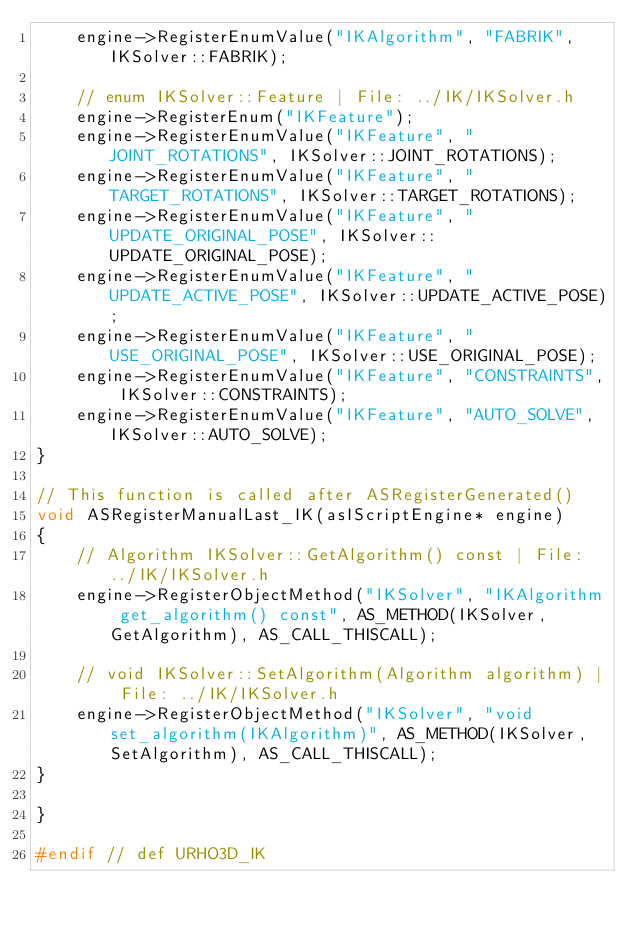<code> <loc_0><loc_0><loc_500><loc_500><_C++_>    engine->RegisterEnumValue("IKAlgorithm", "FABRIK", IKSolver::FABRIK);

    // enum IKSolver::Feature | File: ../IK/IKSolver.h
    engine->RegisterEnum("IKFeature");
    engine->RegisterEnumValue("IKFeature", "JOINT_ROTATIONS", IKSolver::JOINT_ROTATIONS);
    engine->RegisterEnumValue("IKFeature", "TARGET_ROTATIONS", IKSolver::TARGET_ROTATIONS);
    engine->RegisterEnumValue("IKFeature", "UPDATE_ORIGINAL_POSE", IKSolver::UPDATE_ORIGINAL_POSE);
    engine->RegisterEnumValue("IKFeature", "UPDATE_ACTIVE_POSE", IKSolver::UPDATE_ACTIVE_POSE);
    engine->RegisterEnumValue("IKFeature", "USE_ORIGINAL_POSE", IKSolver::USE_ORIGINAL_POSE);
    engine->RegisterEnumValue("IKFeature", "CONSTRAINTS", IKSolver::CONSTRAINTS);
    engine->RegisterEnumValue("IKFeature", "AUTO_SOLVE", IKSolver::AUTO_SOLVE);
}

// This function is called after ASRegisterGenerated()
void ASRegisterManualLast_IK(asIScriptEngine* engine)
{
    // Algorithm IKSolver::GetAlgorithm() const | File: ../IK/IKSolver.h
    engine->RegisterObjectMethod("IKSolver", "IKAlgorithm get_algorithm() const", AS_METHOD(IKSolver, GetAlgorithm), AS_CALL_THISCALL);
    
    // void IKSolver::SetAlgorithm(Algorithm algorithm) | File: ../IK/IKSolver.h
    engine->RegisterObjectMethod("IKSolver", "void set_algorithm(IKAlgorithm)", AS_METHOD(IKSolver, SetAlgorithm), AS_CALL_THISCALL);
}

}

#endif // def URHO3D_IK
</code> 